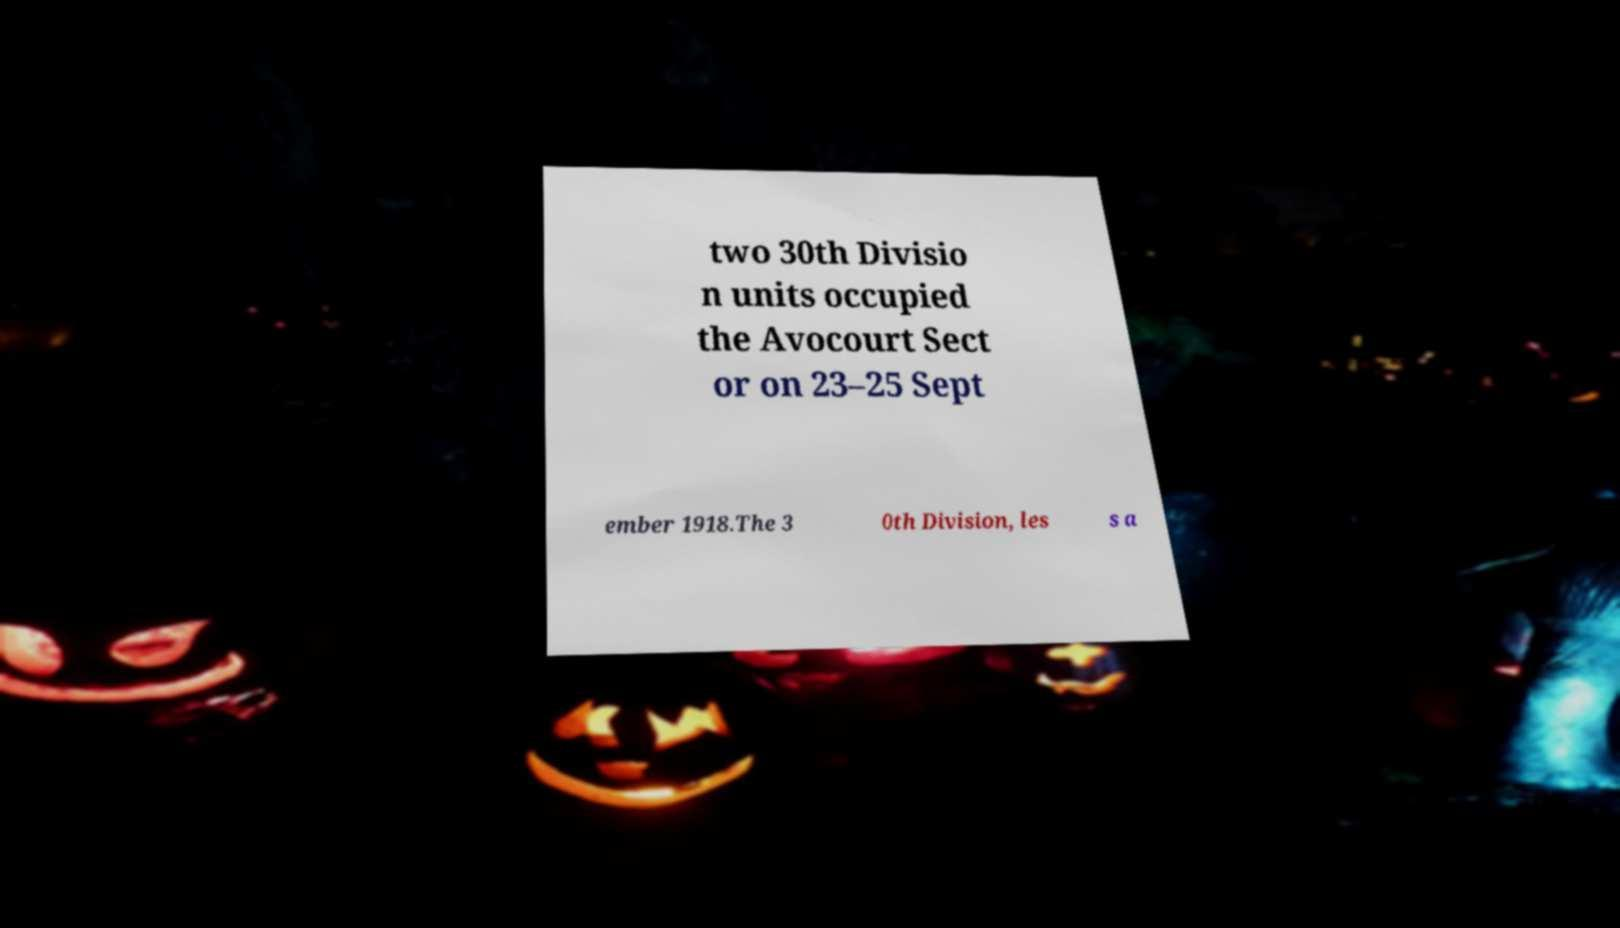Please identify and transcribe the text found in this image. two 30th Divisio n units occupied the Avocourt Sect or on 23–25 Sept ember 1918.The 3 0th Division, les s a 